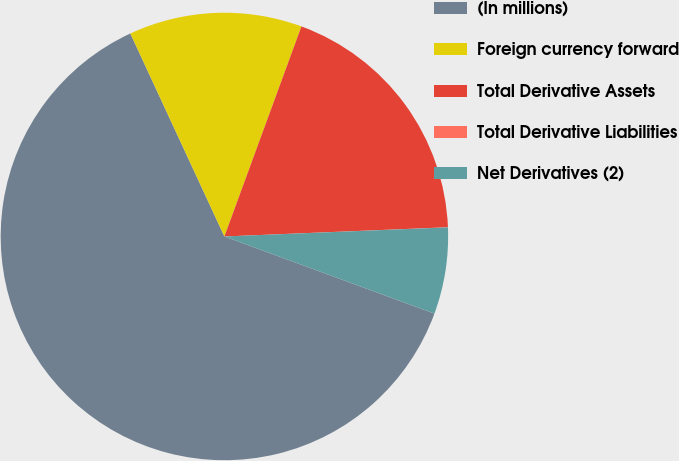Convert chart. <chart><loc_0><loc_0><loc_500><loc_500><pie_chart><fcel>(In millions)<fcel>Foreign currency forward<fcel>Total Derivative Assets<fcel>Total Derivative Liabilities<fcel>Net Derivatives (2)<nl><fcel>62.49%<fcel>12.5%<fcel>18.75%<fcel>0.01%<fcel>6.25%<nl></chart> 